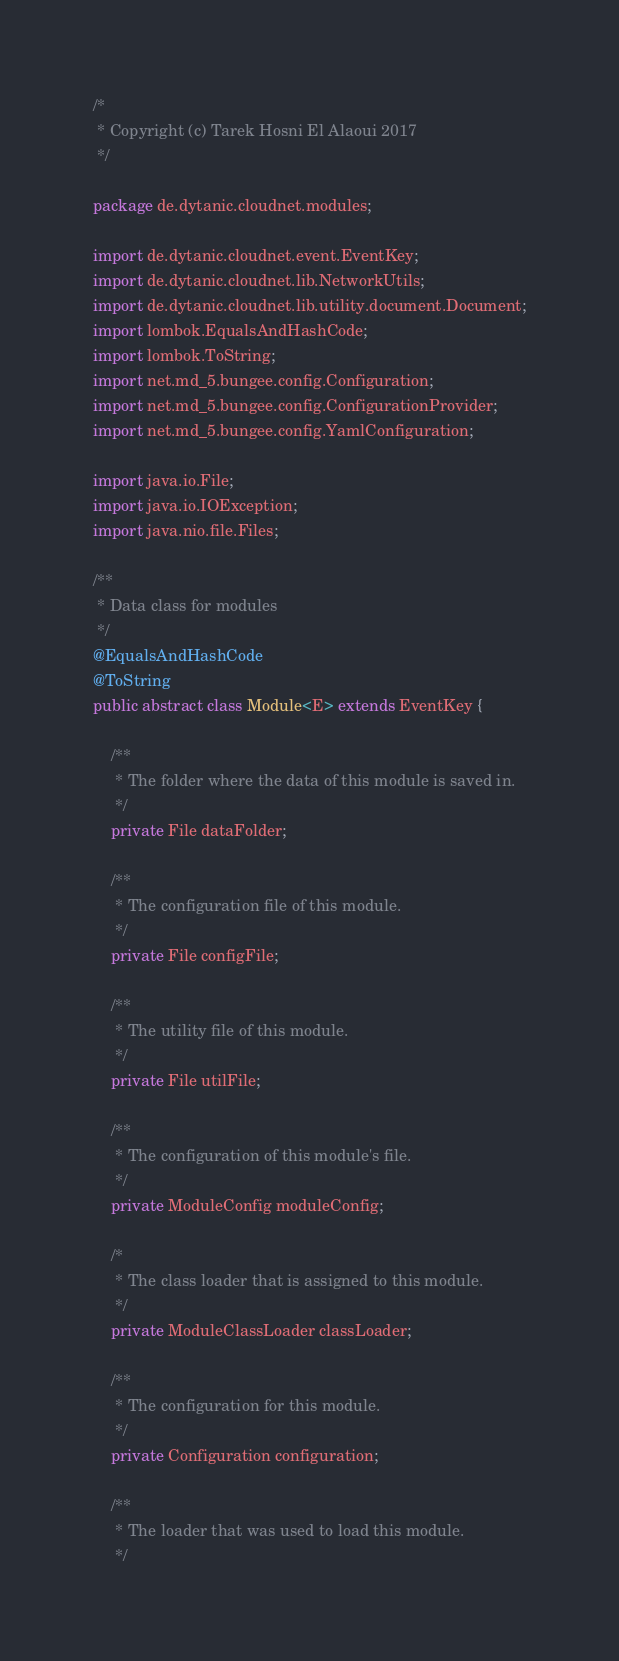Convert code to text. <code><loc_0><loc_0><loc_500><loc_500><_Java_>/*
 * Copyright (c) Tarek Hosni El Alaoui 2017
 */

package de.dytanic.cloudnet.modules;

import de.dytanic.cloudnet.event.EventKey;
import de.dytanic.cloudnet.lib.NetworkUtils;
import de.dytanic.cloudnet.lib.utility.document.Document;
import lombok.EqualsAndHashCode;
import lombok.ToString;
import net.md_5.bungee.config.Configuration;
import net.md_5.bungee.config.ConfigurationProvider;
import net.md_5.bungee.config.YamlConfiguration;

import java.io.File;
import java.io.IOException;
import java.nio.file.Files;

/**
 * Data class for modules
 */
@EqualsAndHashCode
@ToString
public abstract class Module<E> extends EventKey {

    /**
     * The folder where the data of this module is saved in.
     */
    private File dataFolder;

    /**
     * The configuration file of this module.
     */
    private File configFile;

    /**
     * The utility file of this module.
     */
    private File utilFile;

    /**
     * The configuration of this module's file.
     */
    private ModuleConfig moduleConfig;

    /*
     * The class loader that is assigned to this module.
     */
    private ModuleClassLoader classLoader;

    /**
     * The configuration for this module.
     */
    private Configuration configuration;

    /**
     * The loader that was used to load this module.
     */</code> 